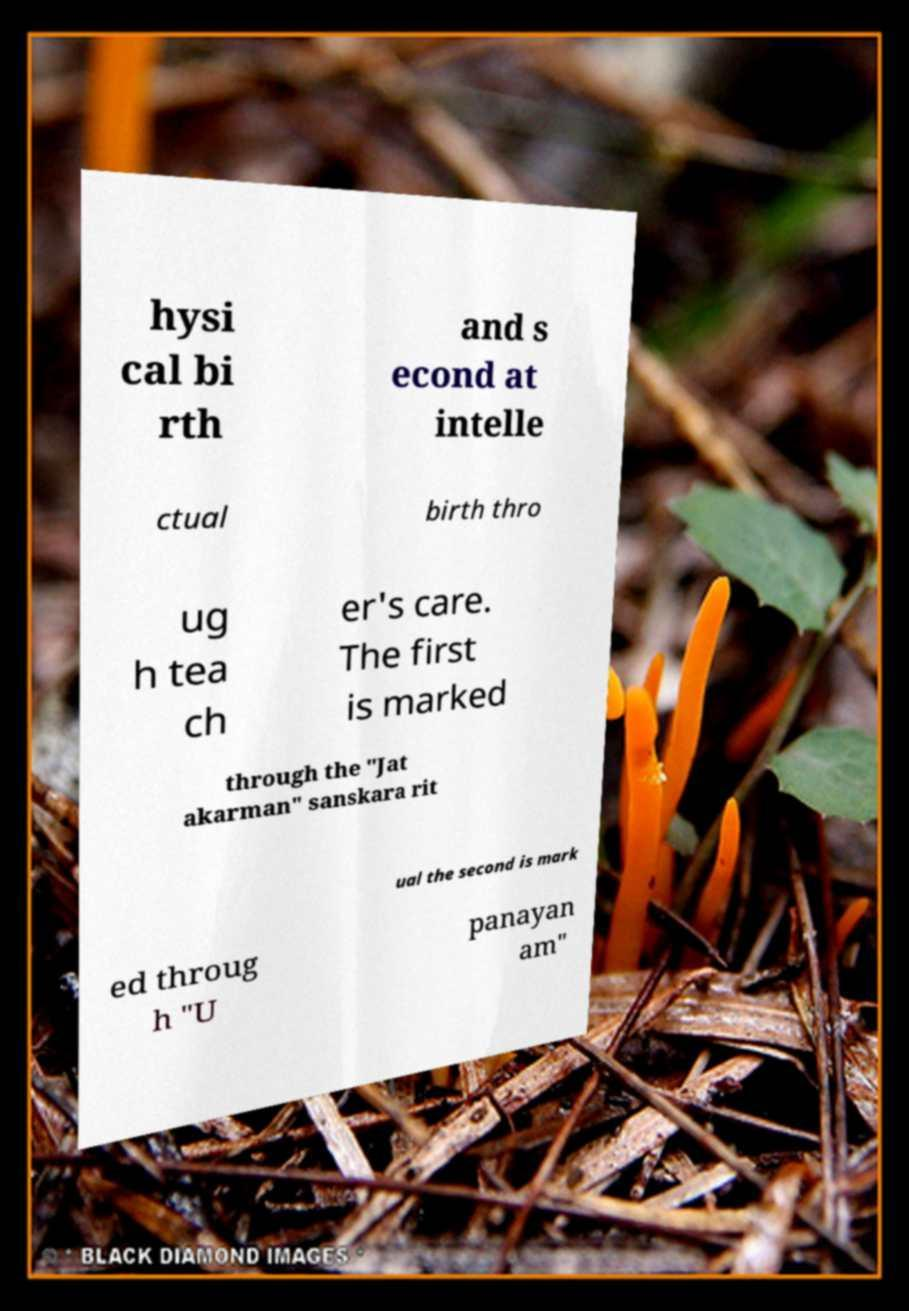What messages or text are displayed in this image? I need them in a readable, typed format. hysi cal bi rth and s econd at intelle ctual birth thro ug h tea ch er's care. The first is marked through the "Jat akarman" sanskara rit ual the second is mark ed throug h "U panayan am" 